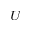<formula> <loc_0><loc_0><loc_500><loc_500>^ { U }</formula> 